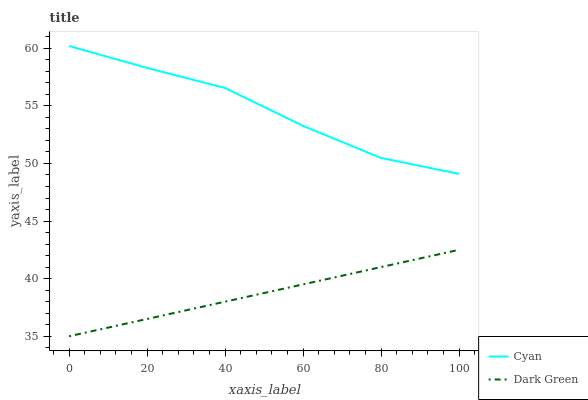Does Dark Green have the maximum area under the curve?
Answer yes or no. No. Is Dark Green the roughest?
Answer yes or no. No. Does Dark Green have the highest value?
Answer yes or no. No. Is Dark Green less than Cyan?
Answer yes or no. Yes. Is Cyan greater than Dark Green?
Answer yes or no. Yes. Does Dark Green intersect Cyan?
Answer yes or no. No. 